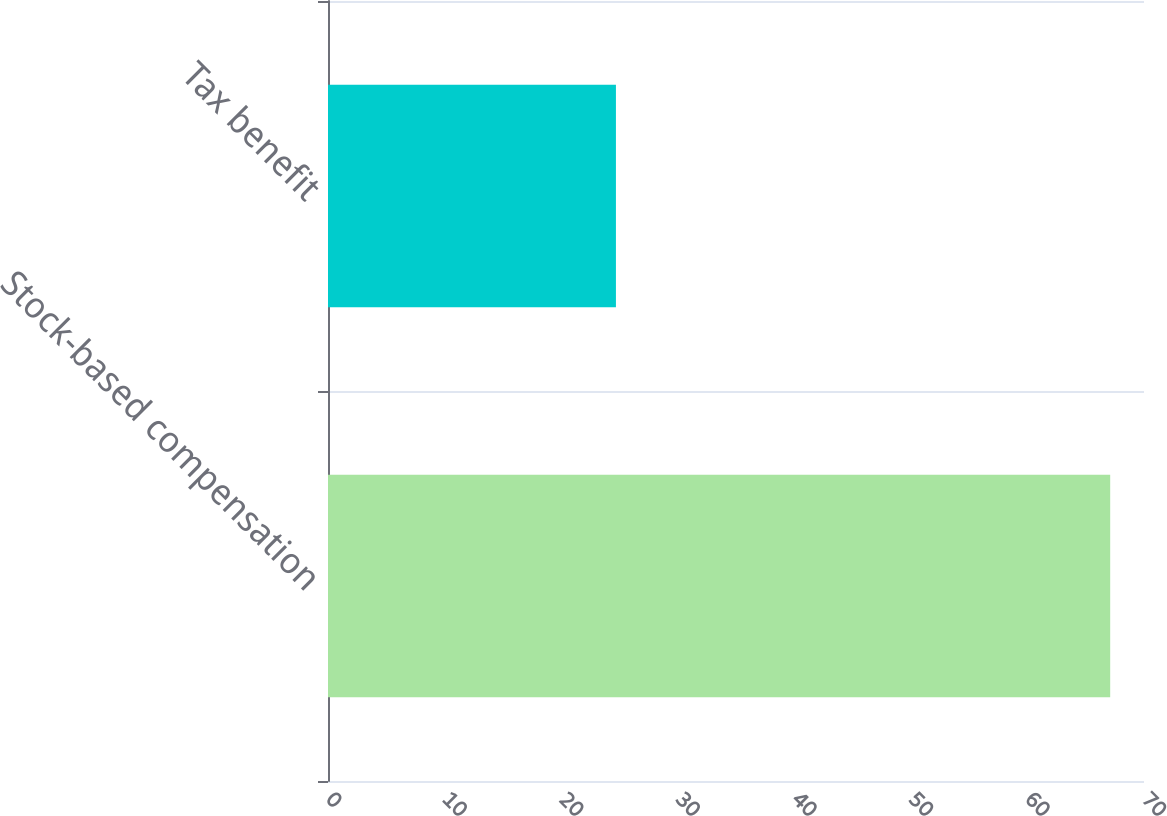<chart> <loc_0><loc_0><loc_500><loc_500><bar_chart><fcel>Stock-based compensation<fcel>Tax benefit<nl><fcel>67.1<fcel>24.7<nl></chart> 